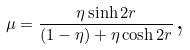<formula> <loc_0><loc_0><loc_500><loc_500>\mu = \frac { \eta \sinh 2 r } { ( 1 - \eta ) + \eta \cosh 2 r } \text {,}</formula> 